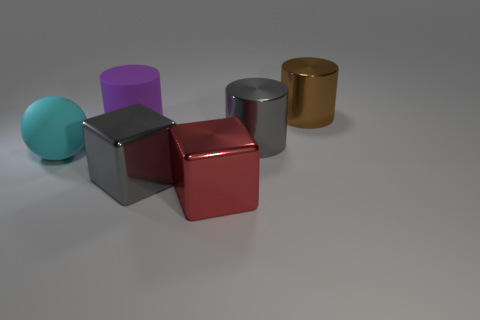What shape is the big gray thing behind the gray object in front of the big gray object behind the large rubber sphere?
Your answer should be very brief. Cylinder. Is the shape of the cyan rubber thing the same as the large gray object on the left side of the big gray cylinder?
Your response must be concise. No. How many small things are either purple rubber cylinders or cyan cubes?
Keep it short and to the point. 0. Is there a purple thing of the same size as the red metal cube?
Ensure brevity in your answer.  Yes. What color is the cube in front of the gray metal object in front of the large metal cylinder in front of the brown cylinder?
Give a very brief answer. Red. Is the material of the large gray cube the same as the large gray object behind the big cyan object?
Provide a succinct answer. Yes. Are there the same number of spheres that are right of the big rubber sphere and matte things that are on the right side of the brown cylinder?
Offer a terse response. Yes. What number of other objects are the same material as the big brown cylinder?
Your response must be concise. 3. Is the number of gray things behind the big cyan matte object the same as the number of large cyan matte balls?
Give a very brief answer. Yes. Is the size of the red metal object the same as the shiny cylinder that is on the left side of the large brown cylinder?
Your answer should be very brief. Yes. 